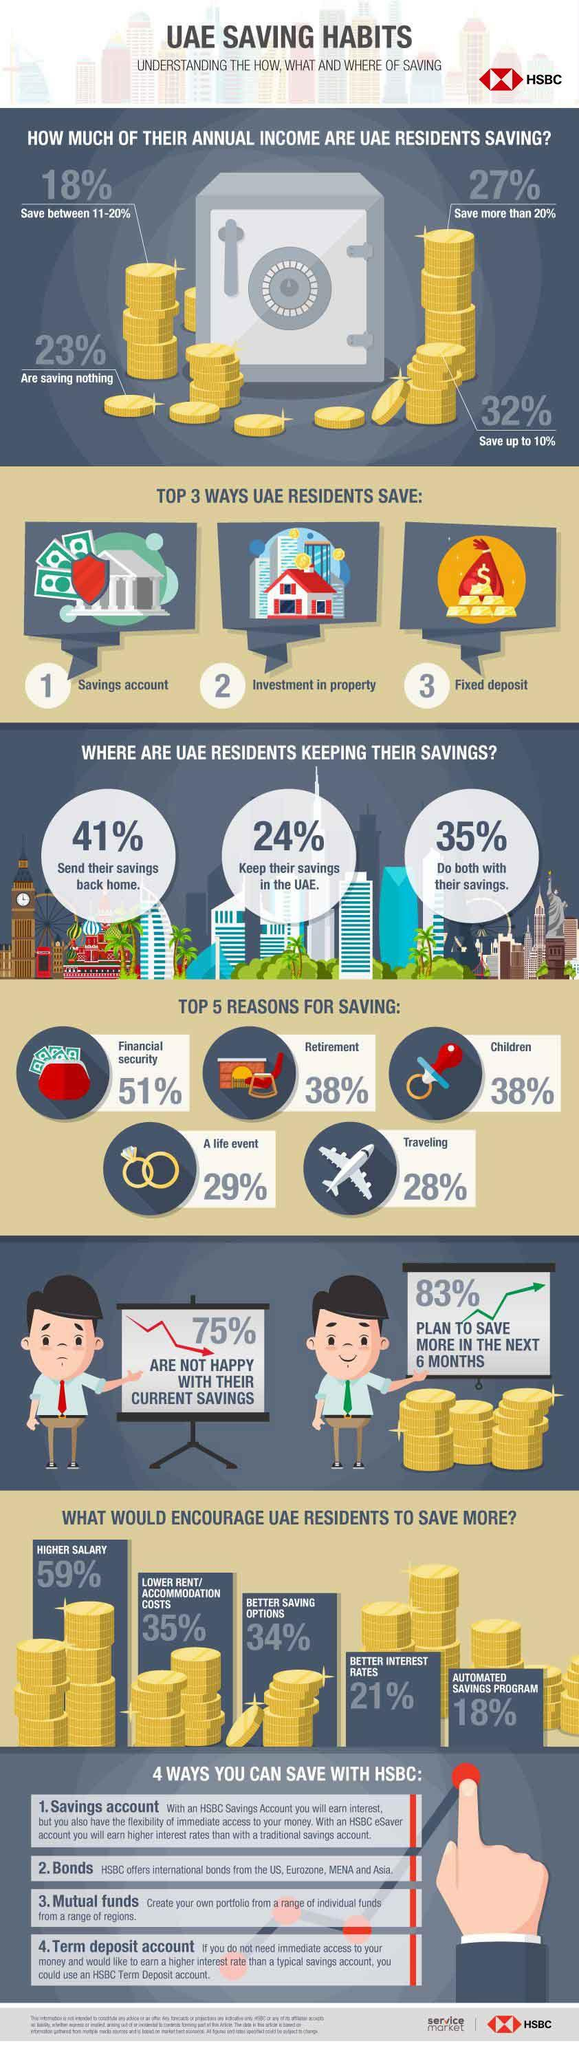Specify some key components in this picture. According to a recent survey, 38% of the people in the UAE save money for both retirement and their children. According to a recent survey, approximately 35% of UAE residents who send money back home also keep their savings in the UAE. In the United Arab Emirates, a small percentage of residents, approximately 4%, save more than 20% of their income, while the vast majority of residents, around 96%, do not save any portion of their income. A recent survey in the UAE revealed that 59%, 34%, and 35% of residents would be willing to save more if rentals were low. The majority of respondents, at 59%, expressed their willingness to save more if the cost of living was reduced. Only 34% of residents indicated that they would not be willing to save more, while 35% of respondents were unsure. A quarter of people are content with their savings. 